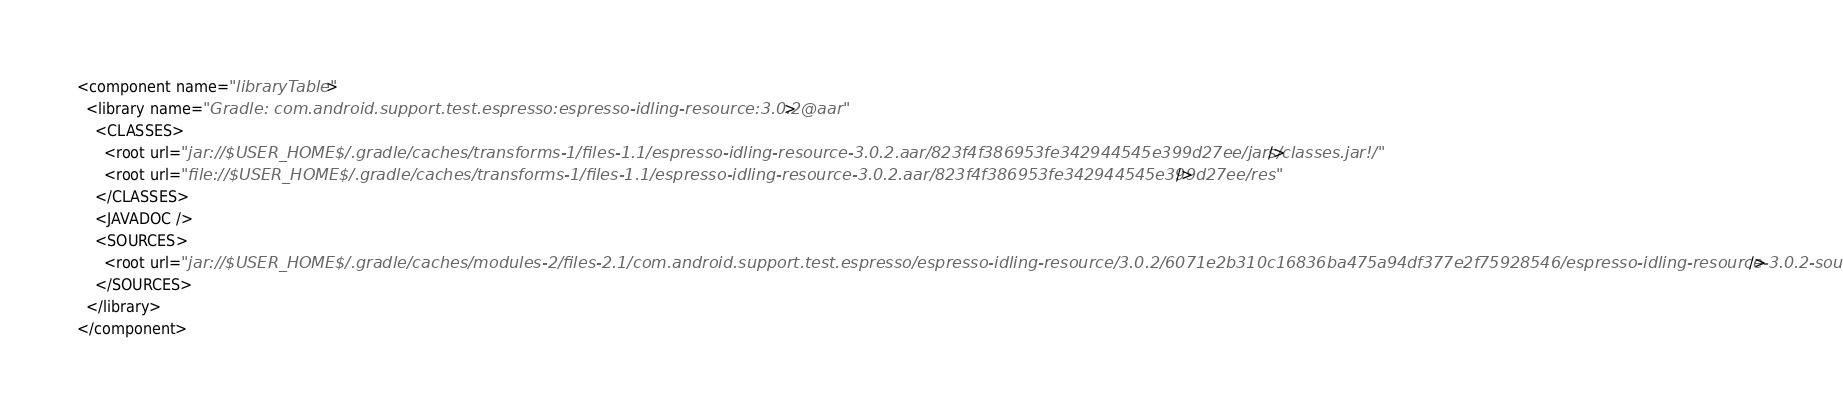<code> <loc_0><loc_0><loc_500><loc_500><_XML_><component name="libraryTable">
  <library name="Gradle: com.android.support.test.espresso:espresso-idling-resource:3.0.2@aar">
    <CLASSES>
      <root url="jar://$USER_HOME$/.gradle/caches/transforms-1/files-1.1/espresso-idling-resource-3.0.2.aar/823f4f386953fe342944545e399d27ee/jars/classes.jar!/" />
      <root url="file://$USER_HOME$/.gradle/caches/transforms-1/files-1.1/espresso-idling-resource-3.0.2.aar/823f4f386953fe342944545e399d27ee/res" />
    </CLASSES>
    <JAVADOC />
    <SOURCES>
      <root url="jar://$USER_HOME$/.gradle/caches/modules-2/files-2.1/com.android.support.test.espresso/espresso-idling-resource/3.0.2/6071e2b310c16836ba475a94df377e2f75928546/espresso-idling-resource-3.0.2-sources.jar!/" />
    </SOURCES>
  </library>
</component></code> 